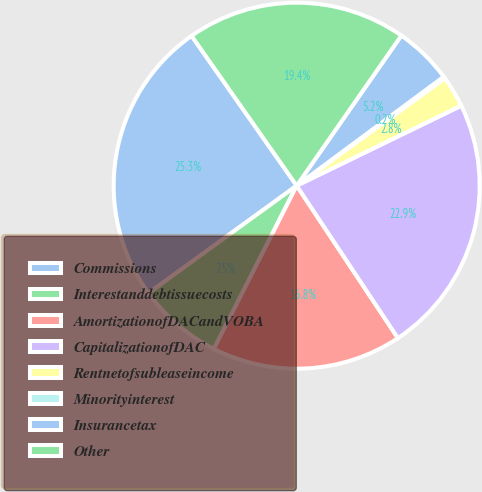Convert chart. <chart><loc_0><loc_0><loc_500><loc_500><pie_chart><fcel>Commissions<fcel>Interestanddebtissuecosts<fcel>AmortizationofDACandVOBA<fcel>CapitalizationofDAC<fcel>Rentnetofsubleaseincome<fcel>Minorityinterest<fcel>Insurancetax<fcel>Other<nl><fcel>25.25%<fcel>7.54%<fcel>16.8%<fcel>22.87%<fcel>2.78%<fcel>0.17%<fcel>5.16%<fcel>19.42%<nl></chart> 